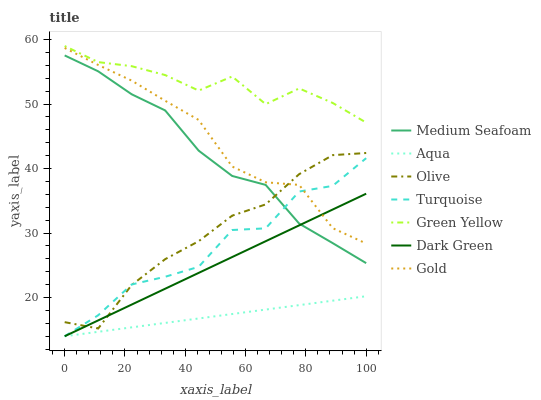Does Aqua have the minimum area under the curve?
Answer yes or no. Yes. Does Green Yellow have the maximum area under the curve?
Answer yes or no. Yes. Does Gold have the minimum area under the curve?
Answer yes or no. No. Does Gold have the maximum area under the curve?
Answer yes or no. No. Is Aqua the smoothest?
Answer yes or no. Yes. Is Turquoise the roughest?
Answer yes or no. Yes. Is Gold the smoothest?
Answer yes or no. No. Is Gold the roughest?
Answer yes or no. No. Does Turquoise have the lowest value?
Answer yes or no. Yes. Does Gold have the lowest value?
Answer yes or no. No. Does Green Yellow have the highest value?
Answer yes or no. Yes. Does Gold have the highest value?
Answer yes or no. No. Is Medium Seafoam less than Green Yellow?
Answer yes or no. Yes. Is Green Yellow greater than Olive?
Answer yes or no. Yes. Does Dark Green intersect Gold?
Answer yes or no. Yes. Is Dark Green less than Gold?
Answer yes or no. No. Is Dark Green greater than Gold?
Answer yes or no. No. Does Medium Seafoam intersect Green Yellow?
Answer yes or no. No. 